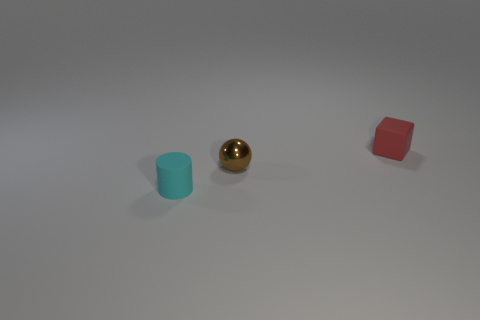Add 2 small cyan rubber cylinders. How many objects exist? 5 Subtract all blocks. How many objects are left? 2 Subtract 0 blue cylinders. How many objects are left? 3 Subtract all tiny blue metal spheres. Subtract all small cyan cylinders. How many objects are left? 2 Add 3 tiny spheres. How many tiny spheres are left? 4 Add 2 small rubber blocks. How many small rubber blocks exist? 3 